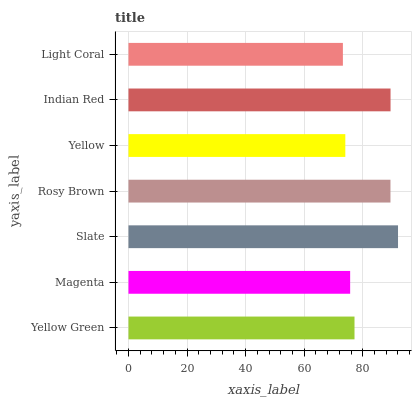Is Light Coral the minimum?
Answer yes or no. Yes. Is Slate the maximum?
Answer yes or no. Yes. Is Magenta the minimum?
Answer yes or no. No. Is Magenta the maximum?
Answer yes or no. No. Is Yellow Green greater than Magenta?
Answer yes or no. Yes. Is Magenta less than Yellow Green?
Answer yes or no. Yes. Is Magenta greater than Yellow Green?
Answer yes or no. No. Is Yellow Green less than Magenta?
Answer yes or no. No. Is Yellow Green the high median?
Answer yes or no. Yes. Is Yellow Green the low median?
Answer yes or no. Yes. Is Rosy Brown the high median?
Answer yes or no. No. Is Light Coral the low median?
Answer yes or no. No. 